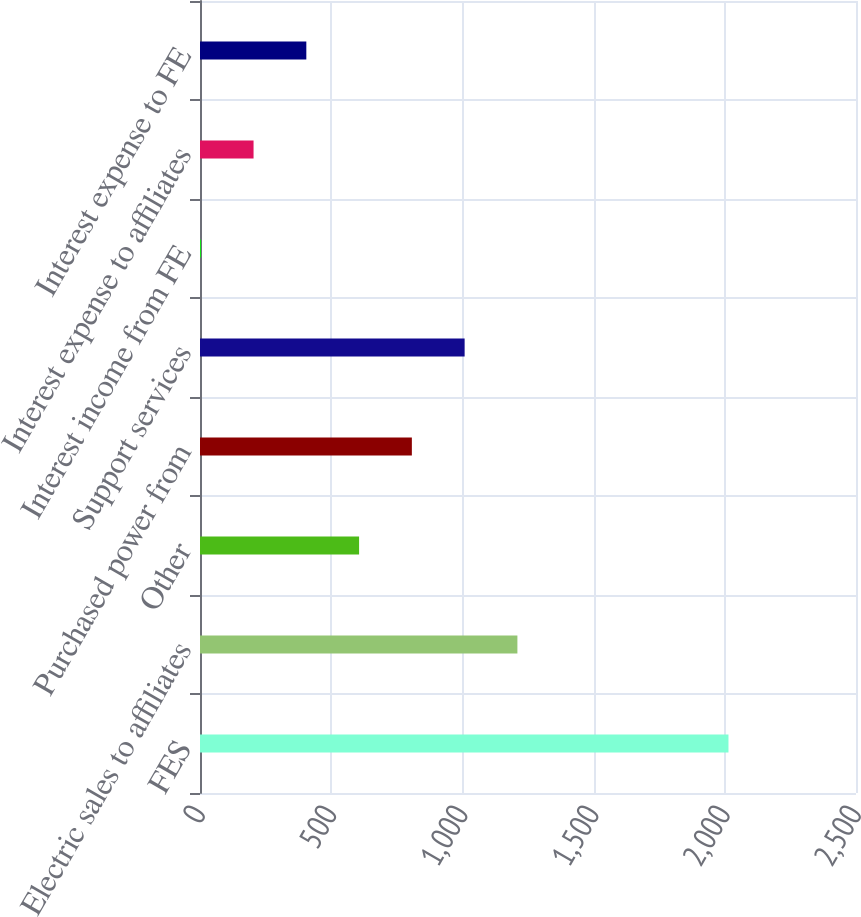<chart> <loc_0><loc_0><loc_500><loc_500><bar_chart><fcel>FES<fcel>Electric sales to affiliates<fcel>Other<fcel>Purchased power from<fcel>Support services<fcel>Interest income from FE<fcel>Interest expense to affiliates<fcel>Interest expense to FE<nl><fcel>2014<fcel>1209.6<fcel>606.3<fcel>807.4<fcel>1008.5<fcel>3<fcel>204.1<fcel>405.2<nl></chart> 